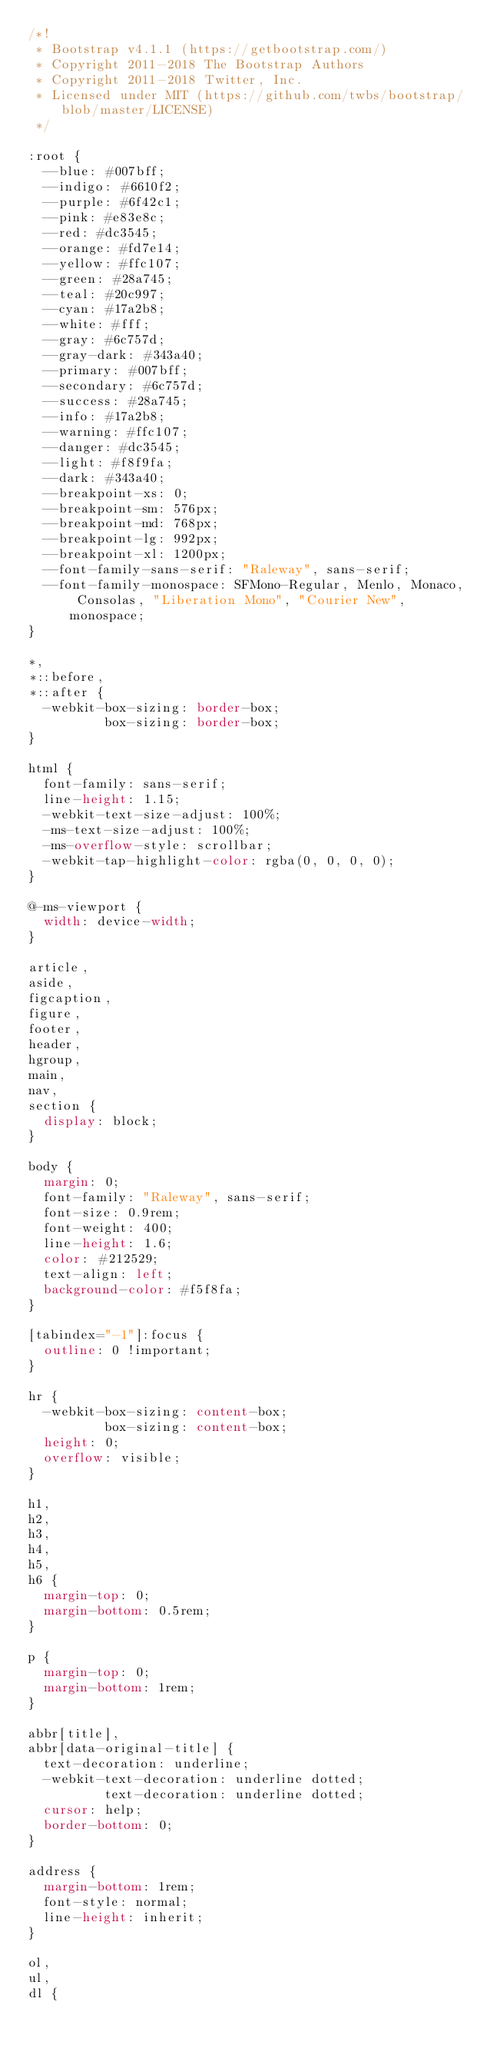Convert code to text. <code><loc_0><loc_0><loc_500><loc_500><_CSS_>/*!
 * Bootstrap v4.1.1 (https://getbootstrap.com/)
 * Copyright 2011-2018 The Bootstrap Authors
 * Copyright 2011-2018 Twitter, Inc.
 * Licensed under MIT (https://github.com/twbs/bootstrap/blob/master/LICENSE)
 */

:root {
  --blue: #007bff;
  --indigo: #6610f2;
  --purple: #6f42c1;
  --pink: #e83e8c;
  --red: #dc3545;
  --orange: #fd7e14;
  --yellow: #ffc107;
  --green: #28a745;
  --teal: #20c997;
  --cyan: #17a2b8;
  --white: #fff;
  --gray: #6c757d;
  --gray-dark: #343a40;
  --primary: #007bff;
  --secondary: #6c757d;
  --success: #28a745;
  --info: #17a2b8;
  --warning: #ffc107;
  --danger: #dc3545;
  --light: #f8f9fa;
  --dark: #343a40;
  --breakpoint-xs: 0;
  --breakpoint-sm: 576px;
  --breakpoint-md: 768px;
  --breakpoint-lg: 992px;
  --breakpoint-xl: 1200px;
  --font-family-sans-serif: "Raleway", sans-serif;
  --font-family-monospace: SFMono-Regular, Menlo, Monaco, Consolas, "Liberation Mono", "Courier New", monospace;
}

*,
*::before,
*::after {
  -webkit-box-sizing: border-box;
          box-sizing: border-box;
}

html {
  font-family: sans-serif;
  line-height: 1.15;
  -webkit-text-size-adjust: 100%;
  -ms-text-size-adjust: 100%;
  -ms-overflow-style: scrollbar;
  -webkit-tap-highlight-color: rgba(0, 0, 0, 0);
}

@-ms-viewport {
  width: device-width;
}

article,
aside,
figcaption,
figure,
footer,
header,
hgroup,
main,
nav,
section {
  display: block;
}

body {
  margin: 0;
  font-family: "Raleway", sans-serif;
  font-size: 0.9rem;
  font-weight: 400;
  line-height: 1.6;
  color: #212529;
  text-align: left;
  background-color: #f5f8fa;
}

[tabindex="-1"]:focus {
  outline: 0 !important;
}

hr {
  -webkit-box-sizing: content-box;
          box-sizing: content-box;
  height: 0;
  overflow: visible;
}

h1,
h2,
h3,
h4,
h5,
h6 {
  margin-top: 0;
  margin-bottom: 0.5rem;
}

p {
  margin-top: 0;
  margin-bottom: 1rem;
}

abbr[title],
abbr[data-original-title] {
  text-decoration: underline;
  -webkit-text-decoration: underline dotted;
          text-decoration: underline dotted;
  cursor: help;
  border-bottom: 0;
}

address {
  margin-bottom: 1rem;
  font-style: normal;
  line-height: inherit;
}

ol,
ul,
dl {</code> 